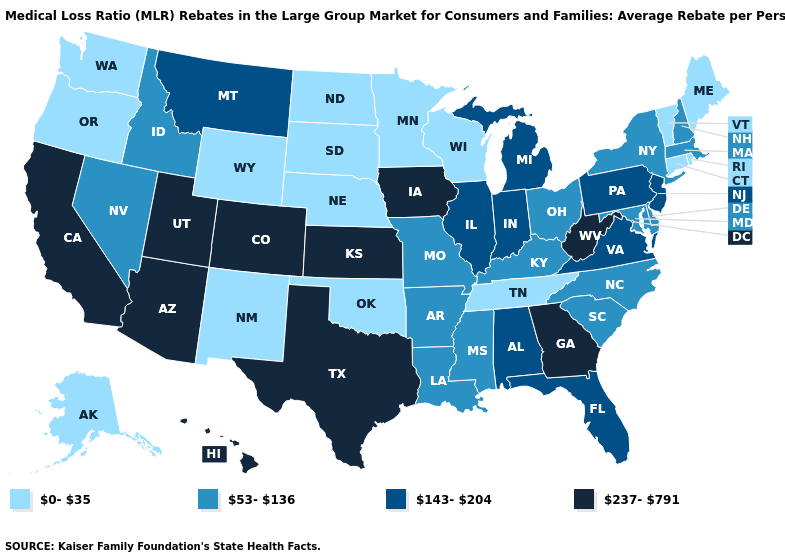What is the lowest value in the Northeast?
Keep it brief. 0-35. What is the value of Colorado?
Be succinct. 237-791. Name the states that have a value in the range 0-35?
Answer briefly. Alaska, Connecticut, Maine, Minnesota, Nebraska, New Mexico, North Dakota, Oklahoma, Oregon, Rhode Island, South Dakota, Tennessee, Vermont, Washington, Wisconsin, Wyoming. What is the value of Virginia?
Write a very short answer. 143-204. Which states hav the highest value in the MidWest?
Write a very short answer. Iowa, Kansas. Does Michigan have the lowest value in the MidWest?
Answer briefly. No. What is the value of South Dakota?
Keep it brief. 0-35. Among the states that border Colorado , which have the highest value?
Write a very short answer. Arizona, Kansas, Utah. What is the value of Florida?
Give a very brief answer. 143-204. What is the value of Vermont?
Write a very short answer. 0-35. Name the states that have a value in the range 143-204?
Give a very brief answer. Alabama, Florida, Illinois, Indiana, Michigan, Montana, New Jersey, Pennsylvania, Virginia. Name the states that have a value in the range 0-35?
Give a very brief answer. Alaska, Connecticut, Maine, Minnesota, Nebraska, New Mexico, North Dakota, Oklahoma, Oregon, Rhode Island, South Dakota, Tennessee, Vermont, Washington, Wisconsin, Wyoming. What is the value of Delaware?
Give a very brief answer. 53-136. Among the states that border Tennessee , does Kentucky have the highest value?
Write a very short answer. No. Among the states that border Arkansas , which have the lowest value?
Short answer required. Oklahoma, Tennessee. 